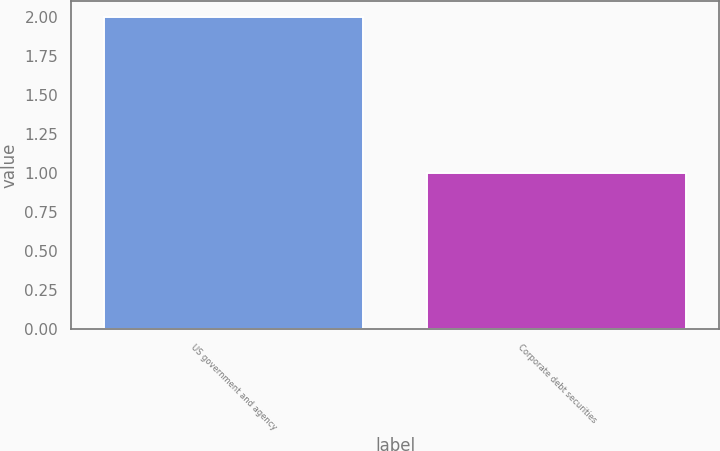Convert chart to OTSL. <chart><loc_0><loc_0><loc_500><loc_500><bar_chart><fcel>US government and agency<fcel>Corporate debt securities<nl><fcel>2<fcel>1<nl></chart> 